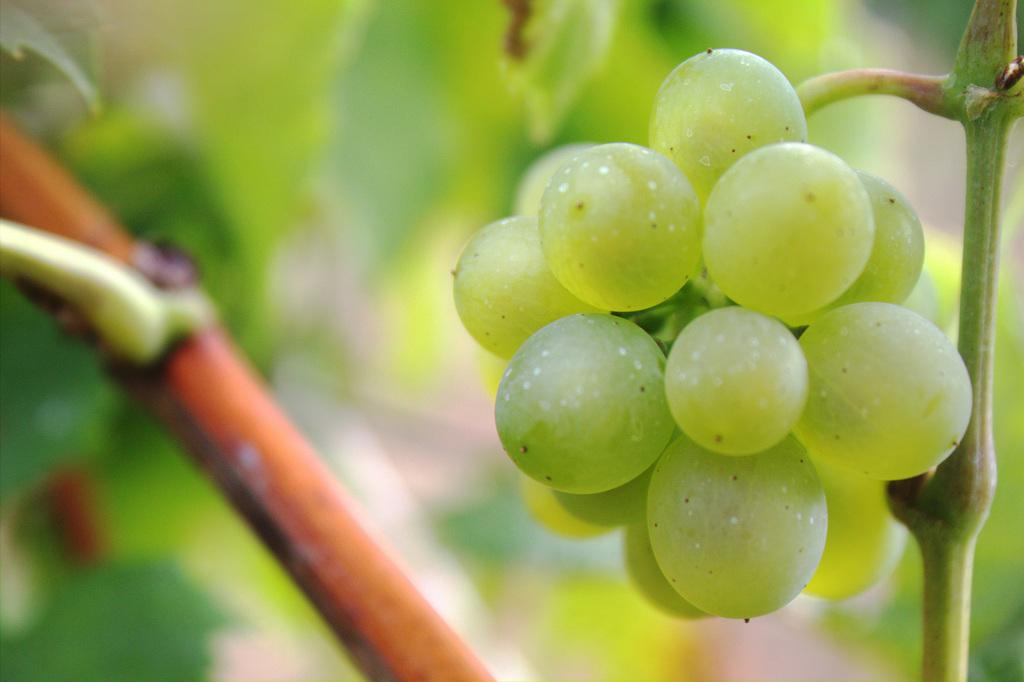What type of fruit is visible in the image? There are grapes in the image. What part of the grapes is also visible in the image? There are stems in the image. Can you describe the background of the image? The background of the image is blurred. What type of mountain range can be seen in the background of the image? There is no mountain range visible in the image; the background is blurred. How many eyes can be seen on the grapes in the image? Grapes do not have eyes, so this question cannot be answered definitively from the image. 